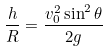<formula> <loc_0><loc_0><loc_500><loc_500>\frac { h } { R } = \frac { v _ { 0 } ^ { 2 } \sin ^ { 2 } \theta } { 2 g }</formula> 